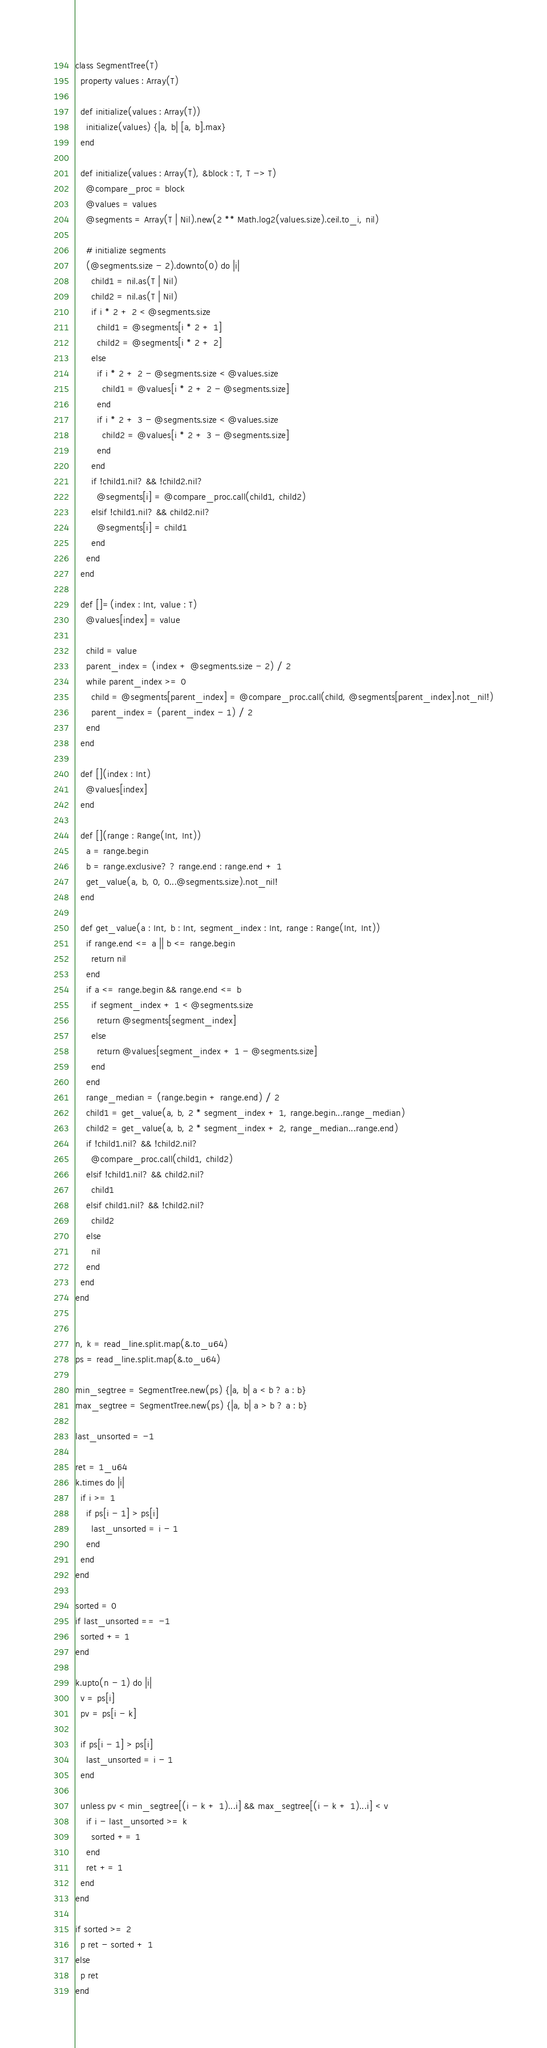<code> <loc_0><loc_0><loc_500><loc_500><_Crystal_>class SegmentTree(T)
  property values : Array(T)

  def initialize(values : Array(T))
    initialize(values) {|a, b| [a, b].max}
  end

  def initialize(values : Array(T), &block : T, T -> T)
    @compare_proc = block
    @values = values
    @segments = Array(T | Nil).new(2 ** Math.log2(values.size).ceil.to_i, nil)

    # initialize segments
    (@segments.size - 2).downto(0) do |i|
      child1 = nil.as(T | Nil)
      child2 = nil.as(T | Nil)
      if i * 2 + 2 < @segments.size
        child1 = @segments[i * 2 + 1]
        child2 = @segments[i * 2 + 2]
      else
        if i * 2 + 2 - @segments.size < @values.size
          child1 = @values[i * 2 + 2 - @segments.size]
        end
        if i * 2 + 3 - @segments.size < @values.size
          child2 = @values[i * 2 + 3 - @segments.size]
        end
      end
      if !child1.nil? && !child2.nil?
        @segments[i] = @compare_proc.call(child1, child2)
      elsif !child1.nil? && child2.nil?
        @segments[i] = child1
      end
    end
  end

  def []=(index : Int, value : T)
    @values[index] = value

    child = value
    parent_index = (index + @segments.size - 2) / 2
    while parent_index >= 0
      child = @segments[parent_index] = @compare_proc.call(child, @segments[parent_index].not_nil!)
      parent_index = (parent_index - 1) / 2
    end
  end

  def [](index : Int)
    @values[index]
  end

  def [](range : Range(Int, Int))
    a = range.begin
    b = range.exclusive? ? range.end : range.end + 1
    get_value(a, b, 0, 0...@segments.size).not_nil!
  end

  def get_value(a : Int, b : Int, segment_index : Int, range : Range(Int, Int))
    if range.end <= a || b <= range.begin
      return nil
    end
    if a <= range.begin && range.end <= b
      if segment_index + 1 < @segments.size
        return @segments[segment_index]
      else
        return @values[segment_index + 1 - @segments.size]
      end
    end
    range_median = (range.begin + range.end) / 2
    child1 = get_value(a, b, 2 * segment_index + 1, range.begin...range_median)
    child2 = get_value(a, b, 2 * segment_index + 2, range_median...range.end)
    if !child1.nil? && !child2.nil?
      @compare_proc.call(child1, child2)
    elsif !child1.nil? && child2.nil?
      child1
    elsif child1.nil? && !child2.nil?
      child2
    else
      nil
    end
  end
end


n, k = read_line.split.map(&.to_u64)
ps = read_line.split.map(&.to_u64)

min_segtree = SegmentTree.new(ps) {|a, b| a < b ? a : b}
max_segtree = SegmentTree.new(ps) {|a, b| a > b ? a : b}

last_unsorted = -1

ret = 1_u64
k.times do |i|
  if i >= 1
    if ps[i - 1] > ps[i]
      last_unsorted = i - 1
    end
  end
end

sorted = 0
if last_unsorted == -1
  sorted += 1
end

k.upto(n - 1) do |i|
  v = ps[i]
  pv = ps[i - k]

  if ps[i - 1] > ps[i]
    last_unsorted = i - 1
  end

  unless pv < min_segtree[(i - k + 1)...i] && max_segtree[(i - k + 1)...i] < v
    if i - last_unsorted >= k
      sorted += 1
    end
    ret += 1
  end
end

if sorted >= 2
  p ret - sorted + 1
else
  p ret
end
</code> 